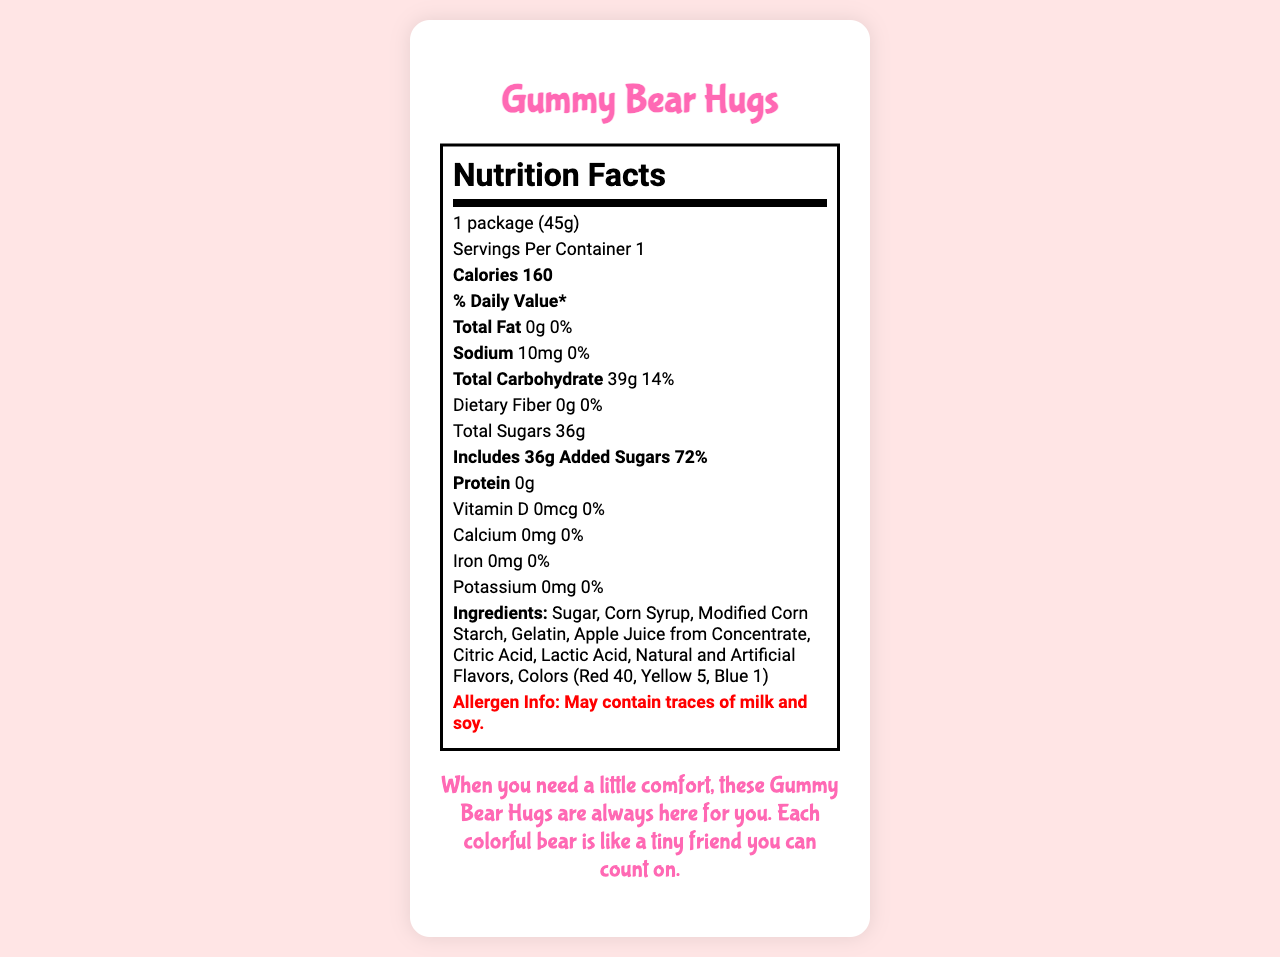what is the product name? The product name is clearly stated at the top of the document in a larger font.
Answer: Gummy Bear Hugs what is the serving size? The serving size is indicated right after the title "Nutrition Facts."
Answer: 1 package (45g) how many calories are in one serving? The calorie count is displayed in a larger, bold font after the servings per container information.
Answer: 160 what is the total carbohydrate content? The total carbohydrate content is listed under the carbohydrate section in the nutrition facts.
Answer: 39g how much added sugar is in one serving? The document mentions that there are 36g of added sugars under the "Total Sugars" section.
Answer: 36g which ingredient is used as a flavoring? The ingredients list Natural and Artificial Flavors, indicating these are used for flavoring.
Answer: Natural and Artificial Flavors does the snack contain any fiber? The nutrition facts clearly state that the dietary fiber content is 0g.
Answer: No how many servings are there in a container? A. 1 B. 2 C. 3 The document states there is 1 serving per container.
Answer: A how much sodium is in the gummy bears? A. 5mg B. 10mg C. 15mg The sodium content is listed as 10mg in the nutrition facts.
Answer: B what is the percentage of daily value for added sugars? 1. 36% 2. 72% 3. 90% According to the nutrition facts, the added sugars percentage of daily value is 72%.
Answer: 2. 72% is this snack suitable for vegetarians or vegans? The document specifies that it is not suitable for vegetarians or vegans under dietary considerations.
Answer: No summarize the main idea of the document. The document aims to inform consumers about the nutritional content and emotional appeal of Gummy Bear Hugs, a high-sugar snack.
Answer: The document provides detailed nutritional information for Gummy Bear Hugs, a sugary comfort snack. It includes serving size, calorie content, macronutrient values, ingredient list, and allergen info, emphasizing its emotional appeal and packaging. what is the source of the apple juice used in the ingredients? The ingredients list specifies "Apple Juice from Concentrate."
Answer: Apple Juice from Concentrate how much protein is in the gummy bears? The protein content is listed as 0g in the nutrition facts.
Answer: 0g does the package contain a resealable pouch? The packaging description mentions that the pouch is resealable.
Answer: Yes does the snack contain any vitamins or minerals? Based on the nutrition facts, the snack does not contain significant amounts of Vitamin D, Calcium, Iron, or Potassium.
Answer: No significant amounts who produces Gummy Bear Hugs? The manufacturer information lists Comfy Snacks, Inc. as the producer.
Answer: Comfy Snacks, Inc. what are the allergens mentioned in the document? The allergen info section states the product may contain traces of milk and soy.
Answer: Milk and soy what emotional appeal is used in the product description? The emotional appeal paragraph emphasizes how the gummy bears provide comfort and a sense of friendship.
Answer: The document mentions that each bear offers a sweet embrace, likening the snack to a tiny friend for comfort. what is the purpose of the lactic acid in the gummy bears? The document does not provide specific information on the function of lactic acid in the gummy bears.
Answer: Cannot be determined 